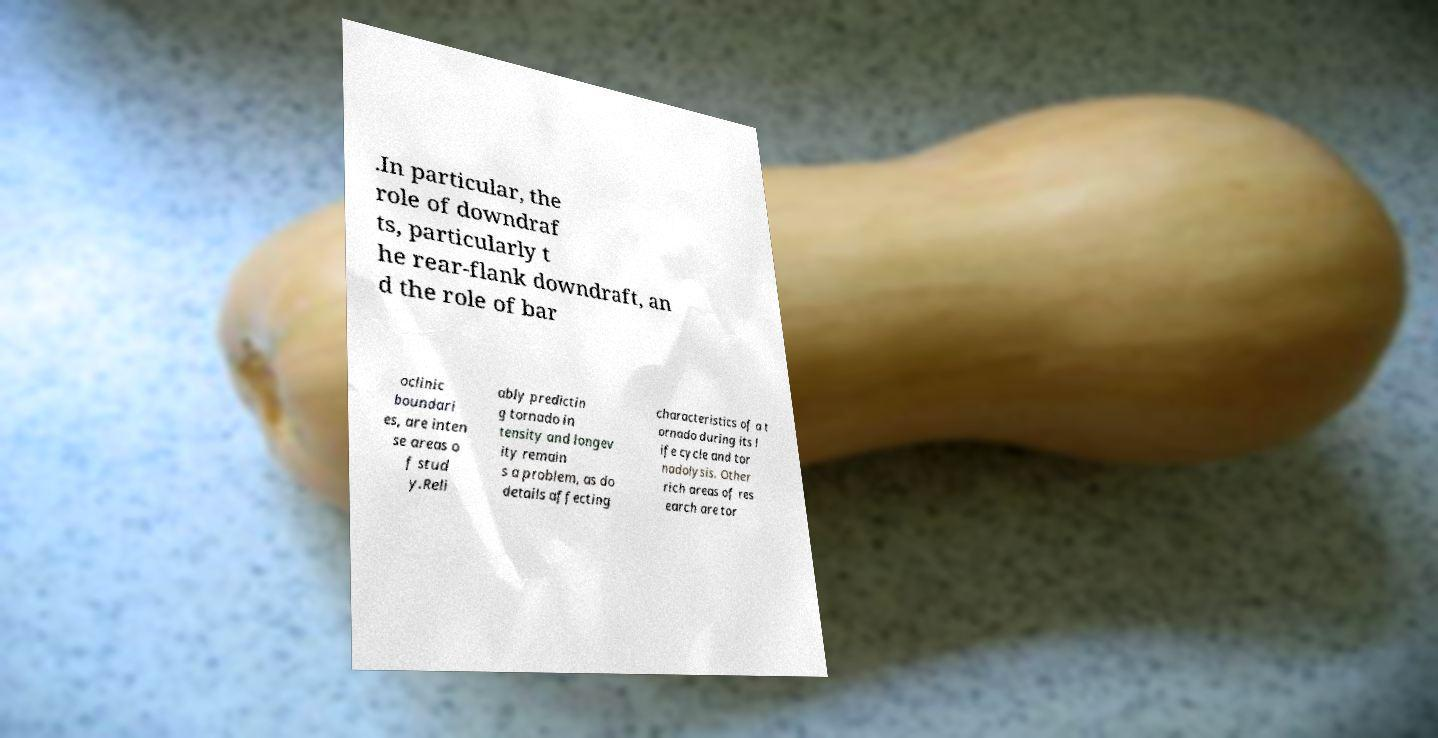What messages or text are displayed in this image? I need them in a readable, typed format. .In particular, the role of downdraf ts, particularly t he rear-flank downdraft, an d the role of bar oclinic boundari es, are inten se areas o f stud y.Reli ably predictin g tornado in tensity and longev ity remain s a problem, as do details affecting characteristics of a t ornado during its l ife cycle and tor nadolysis. Other rich areas of res earch are tor 